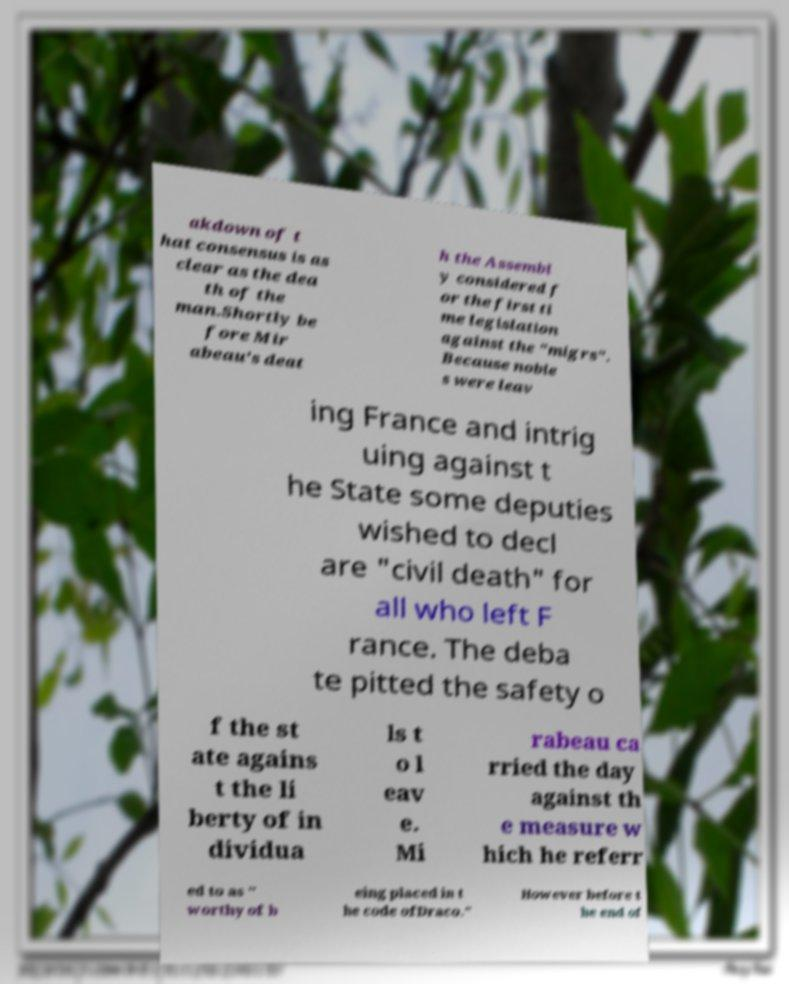Could you extract and type out the text from this image? akdown of t hat consensus is as clear as the dea th of the man.Shortly be fore Mir abeau's deat h the Assembl y considered f or the first ti me legislation against the "migrs". Because noble s were leav ing France and intrig uing against t he State some deputies wished to decl are "civil death" for all who left F rance. The deba te pitted the safety o f the st ate agains t the li berty of in dividua ls t o l eav e. Mi rabeau ca rried the day against th e measure w hich he referr ed to as " worthy of b eing placed in t he code ofDraco." However before t he end of 